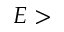Convert formula to latex. <formula><loc_0><loc_0><loc_500><loc_500>E ></formula> 